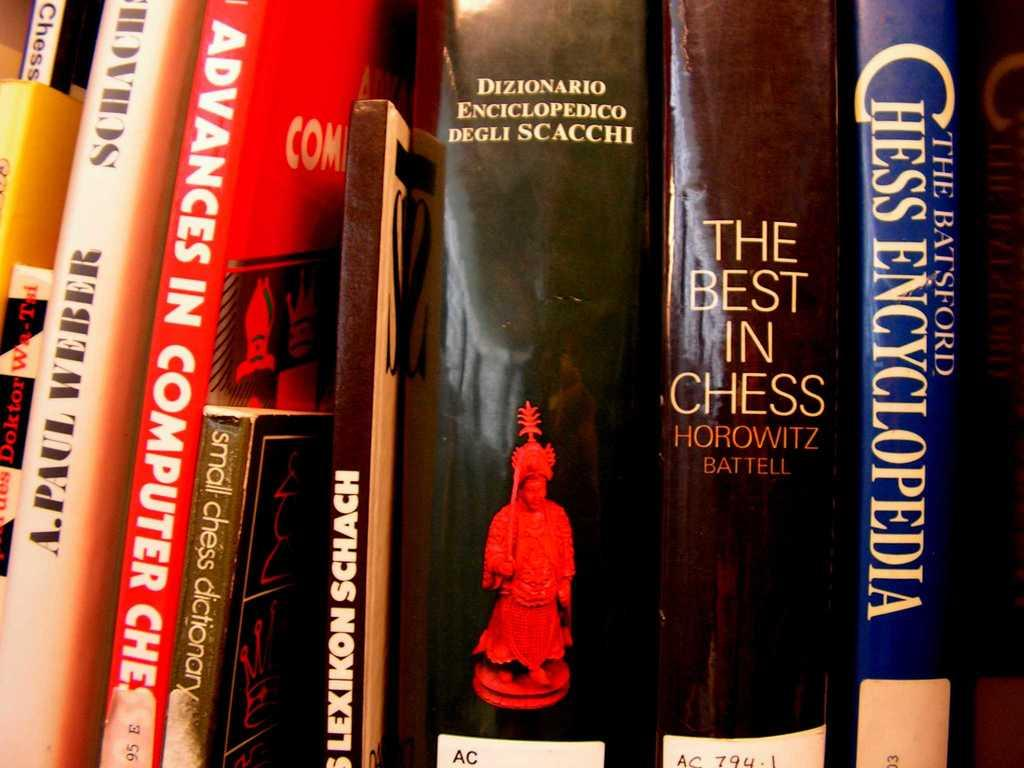<image>
Share a concise interpretation of the image provided. A book collection which includes the best in chess, and advances in computer chess among others. 